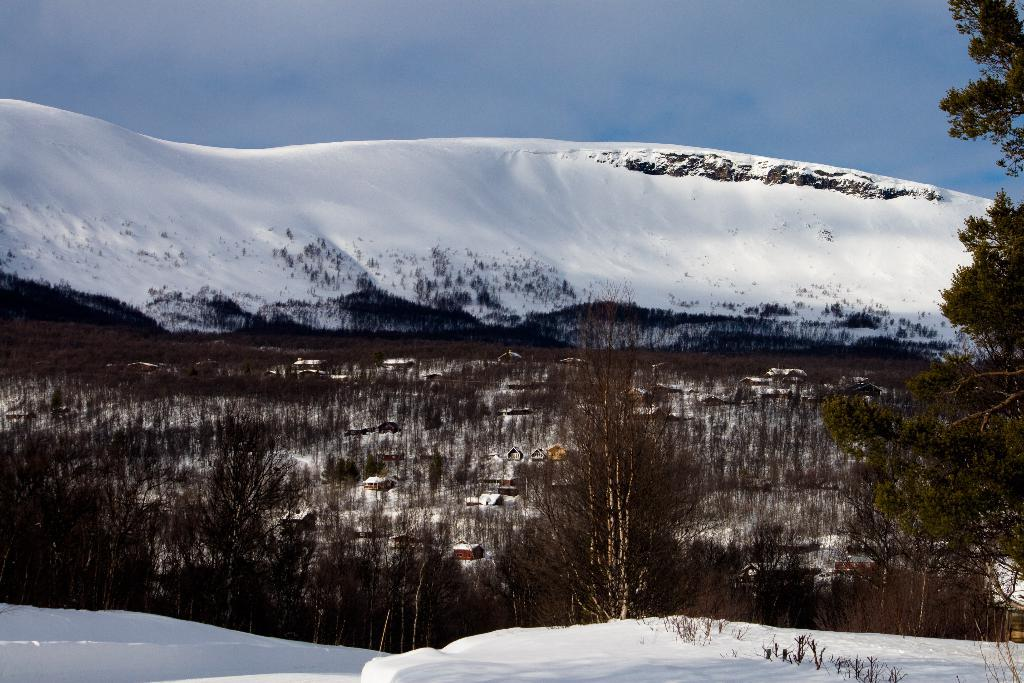What type of weather is depicted in the image? There is snow in the image, indicating a cold or wintery weather condition. What natural features can be seen in the image? There are mountains and trees in the image. What type of human-made structures are present in the image? There are houses in the image. What color is the sky in the background of the image? The sky is blue in the background of the image. Can you see any berries growing on the trees in the image? There are no berries visible on the trees in the image. Is there any fog present in the image? There is no fog visible in the image; the sky is blue in the background. 